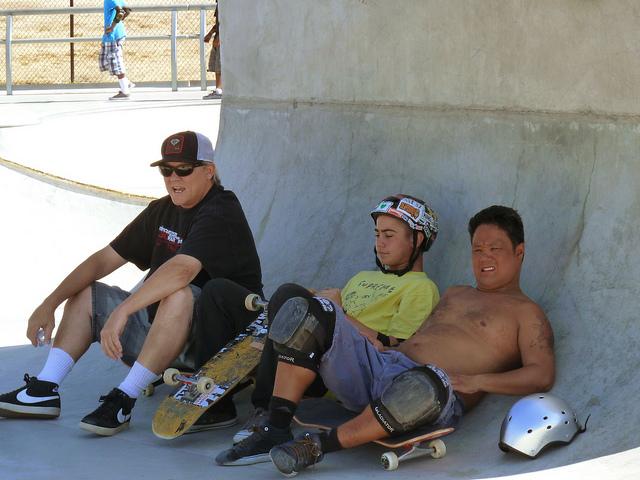Are all three of these men young?
Keep it brief. No. Who wears sunglasses?
Write a very short answer. Man on left. Where are the feet of this skateboarder located?
Write a very short answer. Ground. Are they in the midst of an accident?
Concise answer only. No. 